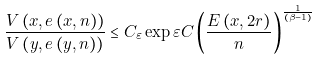Convert formula to latex. <formula><loc_0><loc_0><loc_500><loc_500>\frac { V \left ( x , e \left ( x , n \right ) \right ) } { V \left ( y , e \left ( y , n \right ) \right ) } \leq C _ { \varepsilon } \exp \varepsilon C \left ( \frac { E \left ( x , 2 r \right ) } { n } \right ) ^ { \frac { 1 } { \left ( \beta - 1 \right ) } }</formula> 